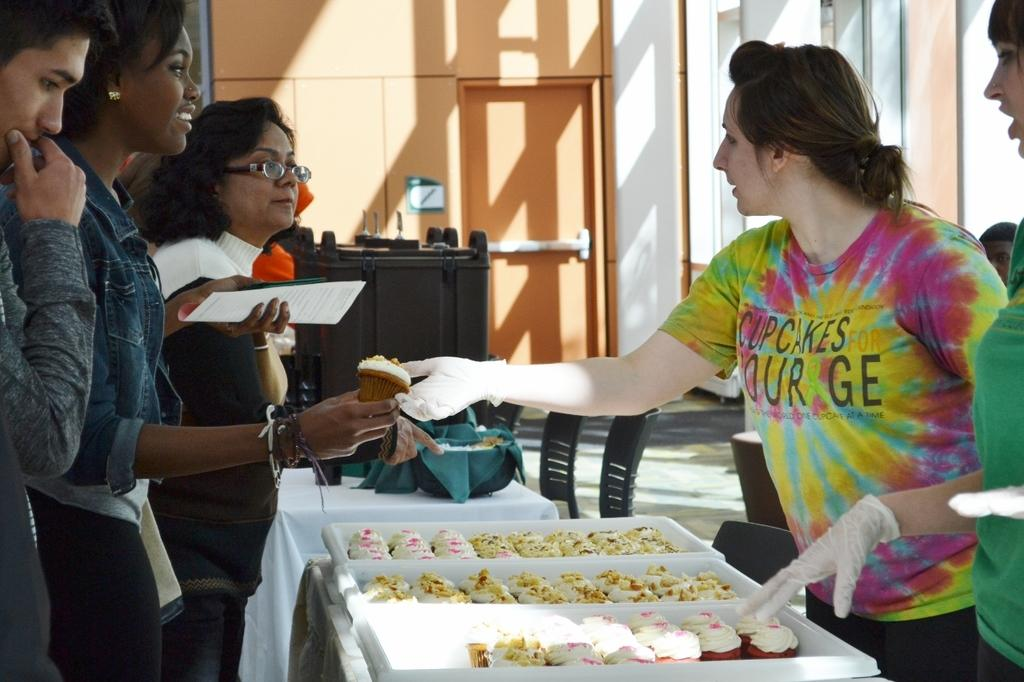How many ladies are in the image? There are two ladies in the image. Where are the ladies located in the image? The ladies are standing in the right corner of the image. How many other persons are present in the image besides the ladies? There are three other persons standing in front of the ladies. What can be seen on a table in front of the group? There are eatables placed on a table in front of the group. What type of collar can be seen on the wren in the image? There is no wren present in the image, and therefore no collar can be observed. 